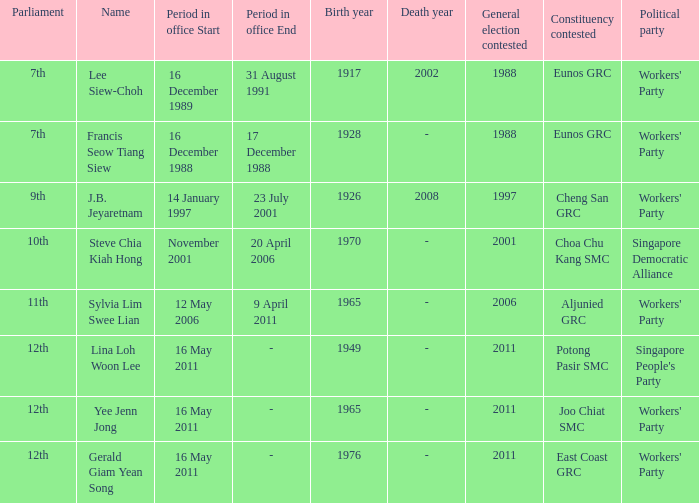What parliament's name is lina loh woon lee? 12th. 